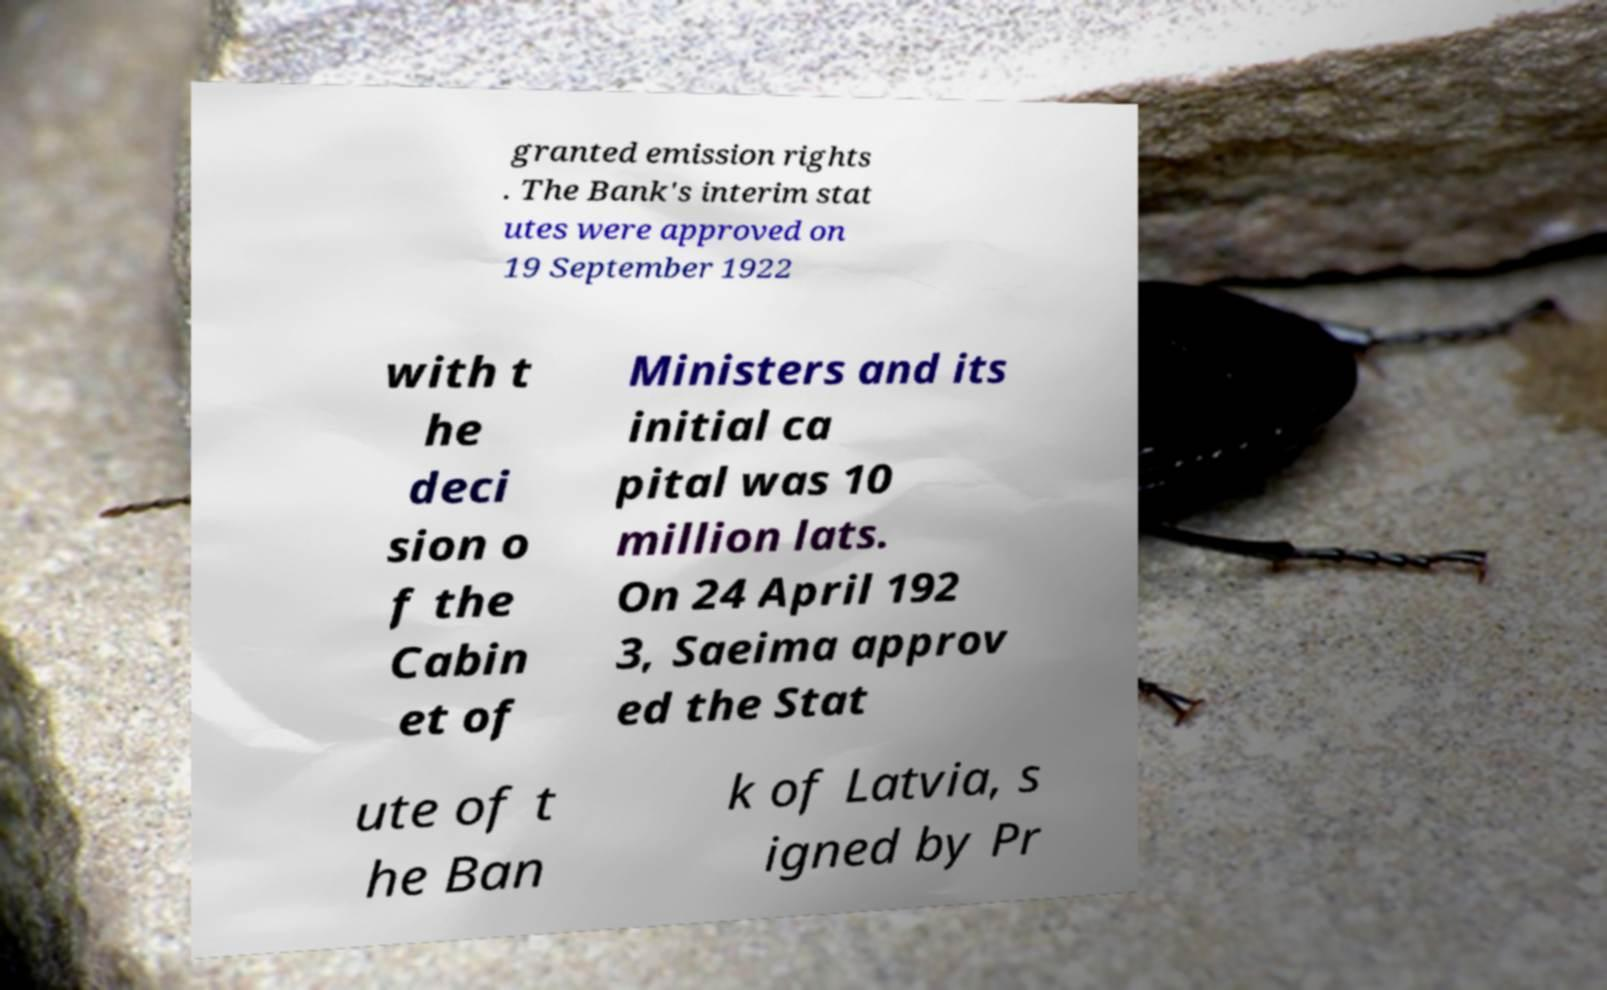Could you extract and type out the text from this image? granted emission rights . The Bank's interim stat utes were approved on 19 September 1922 with t he deci sion o f the Cabin et of Ministers and its initial ca pital was 10 million lats. On 24 April 192 3, Saeima approv ed the Stat ute of t he Ban k of Latvia, s igned by Pr 